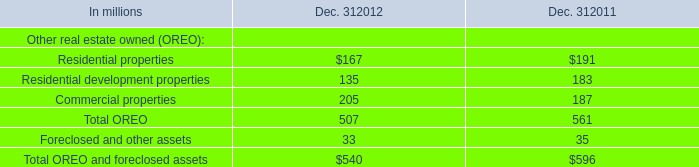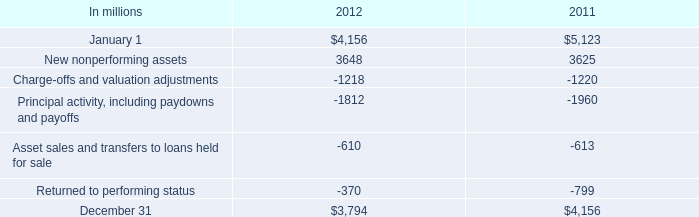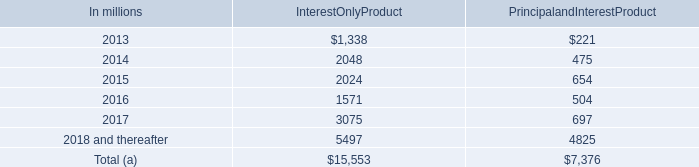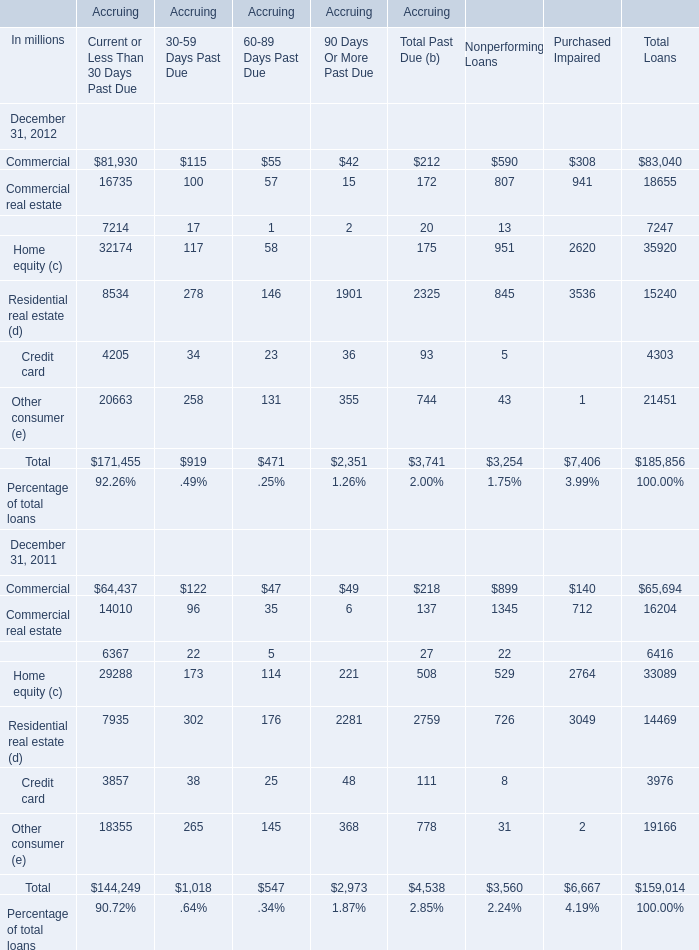In which year is Commercial for Current or Less Than 30 Days Past Due positive? 
Answer: 2012. 